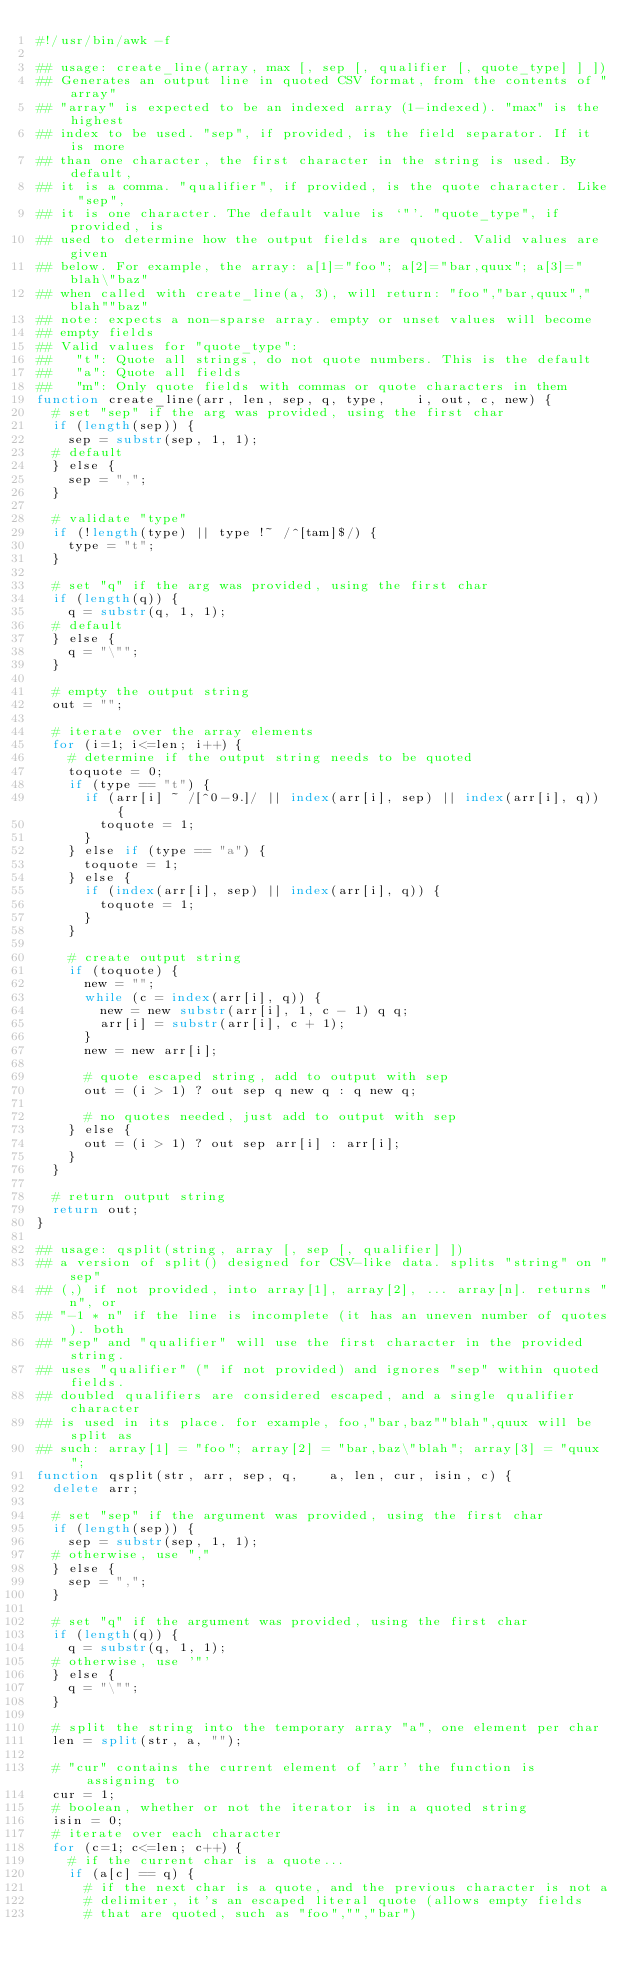<code> <loc_0><loc_0><loc_500><loc_500><_Awk_>#!/usr/bin/awk -f

## usage: create_line(array, max [, sep [, qualifier [, quote_type] ] ])
## Generates an output line in quoted CSV format, from the contents of "array"
## "array" is expected to be an indexed array (1-indexed). "max" is the highest
## index to be used. "sep", if provided, is the field separator. If it is more
## than one character, the first character in the string is used. By default,
## it is a comma. "qualifier", if provided, is the quote character. Like "sep",
## it is one character. The default value is `"'. "quote_type", if provided, is
## used to determine how the output fields are quoted. Valid values are given
## below. For example, the array: a[1]="foo"; a[2]="bar,quux"; a[3]="blah\"baz"
## when called with create_line(a, 3), will return: "foo","bar,quux","blah""baz"
## note: expects a non-sparse array. empty or unset values will become
## empty fields
## Valid values for "quote_type":
##   "t": Quote all strings, do not quote numbers. This is the default
##   "a": Quote all fields
##   "m": Only quote fields with commas or quote characters in them
function create_line(arr, len, sep, q, type,    i, out, c, new) {
  # set "sep" if the arg was provided, using the first char
  if (length(sep)) {
    sep = substr(sep, 1, 1);
  # default
  } else {
    sep = ",";
  }

  # validate "type"
  if (!length(type) || type !~ /^[tam]$/) {
    type = "t";
  }

  # set "q" if the arg was provided, using the first char
  if (length(q)) {
    q = substr(q, 1, 1);
  # default
  } else {
    q = "\"";
  }

  # empty the output string
  out = "";

  # iterate over the array elements
  for (i=1; i<=len; i++) {
    # determine if the output string needs to be quoted
    toquote = 0;
    if (type == "t") {
      if (arr[i] ~ /[^0-9.]/ || index(arr[i], sep) || index(arr[i], q)) {
        toquote = 1;
      }
    } else if (type == "a") {
      toquote = 1;
    } else {
      if (index(arr[i], sep) || index(arr[i], q)) {
        toquote = 1;
      }
    }

    # create output string
    if (toquote) {
      new = "";
      while (c = index(arr[i], q)) {
        new = new substr(arr[i], 1, c - 1) q q;
        arr[i] = substr(arr[i], c + 1);
      }
      new = new arr[i];

      # quote escaped string, add to output with sep
      out = (i > 1) ? out sep q new q : q new q;

      # no quotes needed, just add to output with sep
    } else {
      out = (i > 1) ? out sep arr[i] : arr[i];
    }
  }

  # return output string
  return out;
}

## usage: qsplit(string, array [, sep [, qualifier] ])
## a version of split() designed for CSV-like data. splits "string" on "sep"
## (,) if not provided, into array[1], array[2], ... array[n]. returns "n", or
## "-1 * n" if the line is incomplete (it has an uneven number of quotes). both
## "sep" and "qualifier" will use the first character in the provided string.
## uses "qualifier" (" if not provided) and ignores "sep" within quoted fields.
## doubled qualifiers are considered escaped, and a single qualifier character
## is used in its place. for example, foo,"bar,baz""blah",quux will be split as
## such: array[1] = "foo"; array[2] = "bar,baz\"blah"; array[3] = "quux";
function qsplit(str, arr, sep, q,    a, len, cur, isin, c) {
  delete arr;

  # set "sep" if the argument was provided, using the first char
  if (length(sep)) {
    sep = substr(sep, 1, 1);
  # otherwise, use ","
  } else {
    sep = ",";
  }

  # set "q" if the argument was provided, using the first char
  if (length(q)) {
    q = substr(q, 1, 1);
  # otherwise, use '"'
  } else {
    q = "\"";
  }

  # split the string into the temporary array "a", one element per char
  len = split(str, a, "");

  # "cur" contains the current element of 'arr' the function is assigning to
  cur = 1;
  # boolean, whether or not the iterator is in a quoted string
  isin = 0;
  # iterate over each character
  for (c=1; c<=len; c++) {
    # if the current char is a quote...
    if (a[c] == q) {
      # if the next char is a quote, and the previous character is not a
      # delimiter, it's an escaped literal quote (allows empty fields 
      # that are quoted, such as "foo","","bar")</code> 